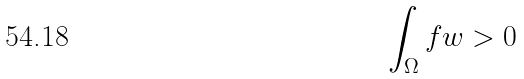Convert formula to latex. <formula><loc_0><loc_0><loc_500><loc_500>\int _ { \Omega } f w > 0</formula> 